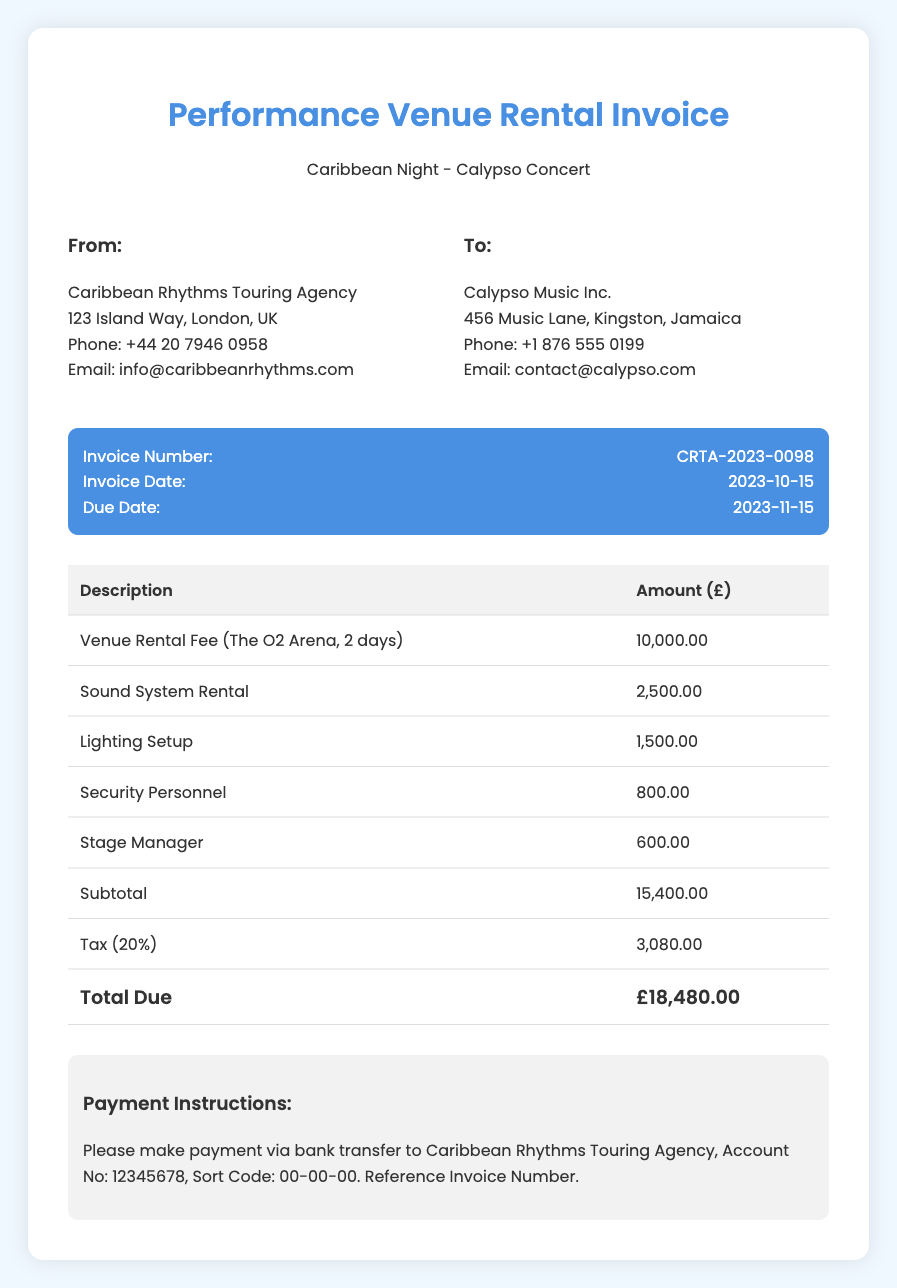What is the invoice number? The invoice number is specified in the document to uniquely identify the invoice.
Answer: CRTA-2023-0098 What is the total due amount? The total due amount is the final figure calculated after the subtotal and tax are added together.
Answer: £18,480.00 What is the venue for the concert? The venue is mentioned in the document as the location where the concert will take place.
Answer: The O2 Arena How many days was the venue rented? The duration of the rental period is clearly stated in the description of the venue rental fee.
Answer: 2 days What is the date of the invoice? The date is provided and indicates when the invoice was issued.
Answer: 2023-10-15 What services were included besides the venue rental? The additional services are detailed in the table, indicating what else was rented or provided.
Answer: Sound System Rental, Lighting Setup, Security Personnel, Stage Manager What percentage is the tax applied to the subtotal? The tax percentage is mentioned explicitly in the document, linking it to the subtotal.
Answer: 20% What is the due date for payment? The due date is specified in the invoice to indicate when payment must be completed.
Answer: 2023-11-15 How can the payment be made? Instructions for making the payment are outlined in a specific section of the document.
Answer: Bank transfer to Caribbean Rhythms Touring Agency 